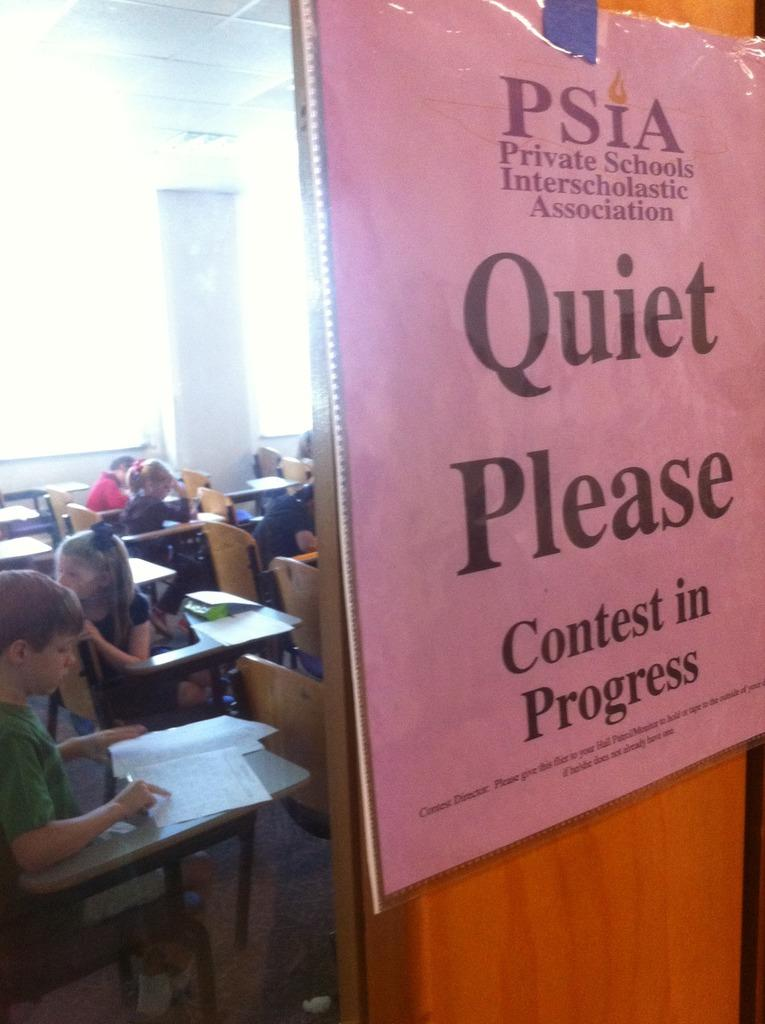<image>
Summarize the visual content of the image. A purple sign on a classroom door says quiet please. 